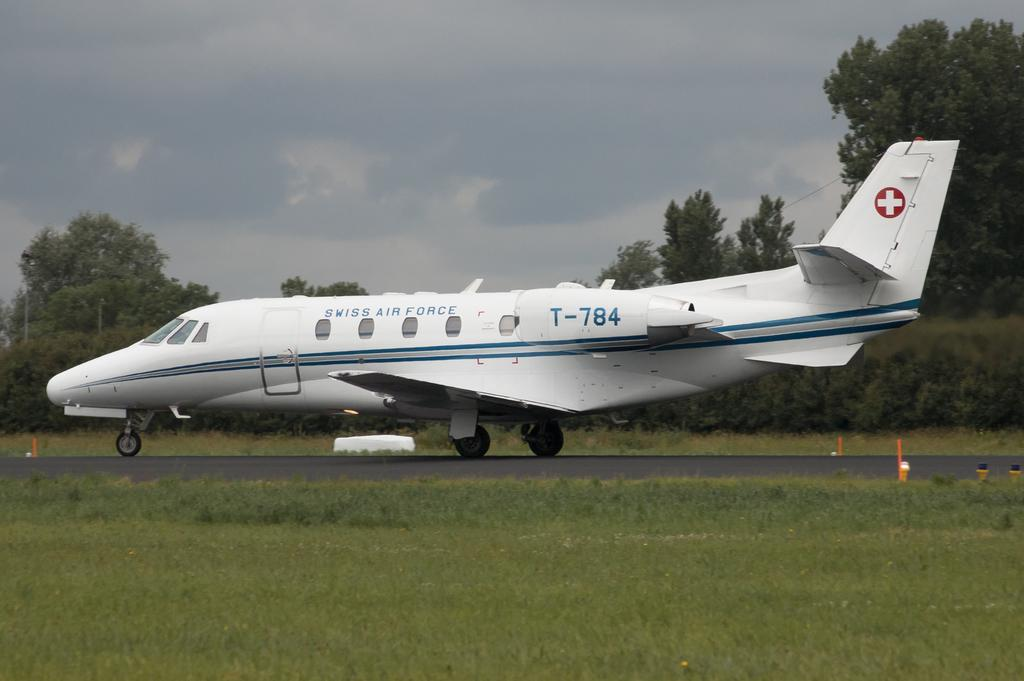What is the main subject of the image? The main subject of the image is an airplane on the runway. What type of vegetation is present at the bottom of the image? There is grass at the bottom of the image. What can be seen in the background of the image? There are trees and the sky visible in the background of the image. What type of silk fabric is draped over the airplane in the image? There is no silk fabric present in the image; the airplane is on the runway without any additional decorations or materials. 